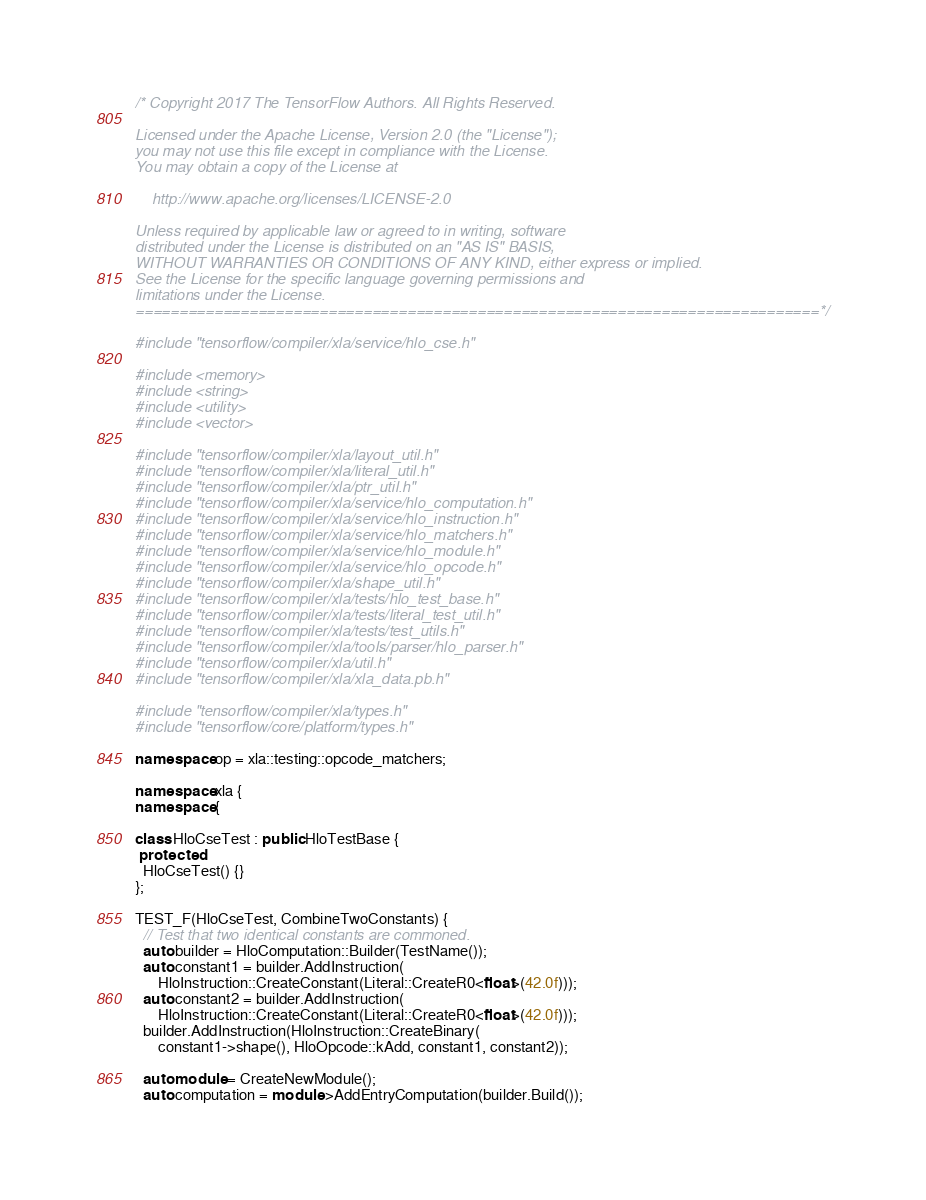Convert code to text. <code><loc_0><loc_0><loc_500><loc_500><_C++_>/* Copyright 2017 The TensorFlow Authors. All Rights Reserved.

Licensed under the Apache License, Version 2.0 (the "License");
you may not use this file except in compliance with the License.
You may obtain a copy of the License at

    http://www.apache.org/licenses/LICENSE-2.0

Unless required by applicable law or agreed to in writing, software
distributed under the License is distributed on an "AS IS" BASIS,
WITHOUT WARRANTIES OR CONDITIONS OF ANY KIND, either express or implied.
See the License for the specific language governing permissions and
limitations under the License.
==============================================================================*/

#include "tensorflow/compiler/xla/service/hlo_cse.h"

#include <memory>
#include <string>
#include <utility>
#include <vector>

#include "tensorflow/compiler/xla/layout_util.h"
#include "tensorflow/compiler/xla/literal_util.h"
#include "tensorflow/compiler/xla/ptr_util.h"
#include "tensorflow/compiler/xla/service/hlo_computation.h"
#include "tensorflow/compiler/xla/service/hlo_instruction.h"
#include "tensorflow/compiler/xla/service/hlo_matchers.h"
#include "tensorflow/compiler/xla/service/hlo_module.h"
#include "tensorflow/compiler/xla/service/hlo_opcode.h"
#include "tensorflow/compiler/xla/shape_util.h"
#include "tensorflow/compiler/xla/tests/hlo_test_base.h"
#include "tensorflow/compiler/xla/tests/literal_test_util.h"
#include "tensorflow/compiler/xla/tests/test_utils.h"
#include "tensorflow/compiler/xla/tools/parser/hlo_parser.h"
#include "tensorflow/compiler/xla/util.h"
#include "tensorflow/compiler/xla/xla_data.pb.h"

#include "tensorflow/compiler/xla/types.h"
#include "tensorflow/core/platform/types.h"

namespace op = xla::testing::opcode_matchers;

namespace xla {
namespace {

class HloCseTest : public HloTestBase {
 protected:
  HloCseTest() {}
};

TEST_F(HloCseTest, CombineTwoConstants) {
  // Test that two identical constants are commoned.
  auto builder = HloComputation::Builder(TestName());
  auto constant1 = builder.AddInstruction(
      HloInstruction::CreateConstant(Literal::CreateR0<float>(42.0f)));
  auto constant2 = builder.AddInstruction(
      HloInstruction::CreateConstant(Literal::CreateR0<float>(42.0f)));
  builder.AddInstruction(HloInstruction::CreateBinary(
      constant1->shape(), HloOpcode::kAdd, constant1, constant2));

  auto module = CreateNewModule();
  auto computation = module->AddEntryComputation(builder.Build());
</code> 